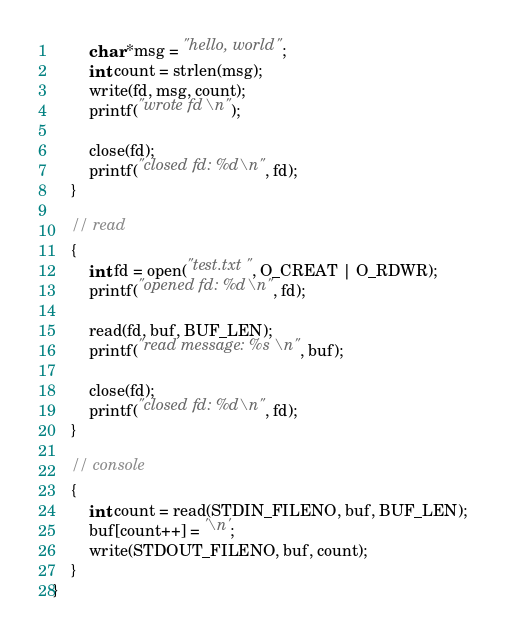Convert code to text. <code><loc_0><loc_0><loc_500><loc_500><_C_>
        char *msg = "hello, world";
        int count = strlen(msg);
        write(fd, msg, count);
        printf("wrote fd\n");

        close(fd);
        printf("closed fd: %d\n", fd);
    }

    // read
    {
        int fd = open("test.txt", O_CREAT | O_RDWR);
        printf("opened fd: %d\n", fd);

        read(fd, buf, BUF_LEN);
        printf("read message: %s\n", buf);

        close(fd);
        printf("closed fd: %d\n", fd);
    }

    // console
    {
        int count = read(STDIN_FILENO, buf, BUF_LEN);
        buf[count++] = '\n';
        write(STDOUT_FILENO, buf, count);
    }
}
</code> 